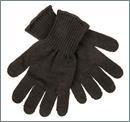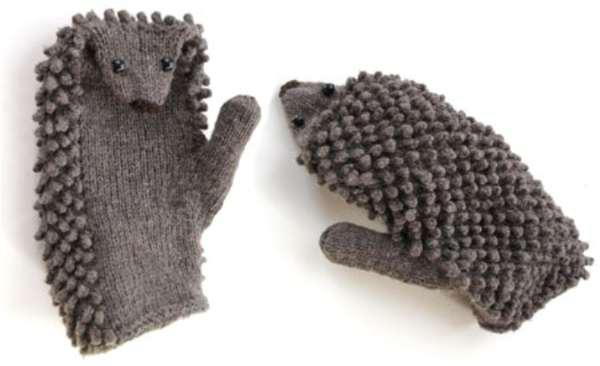The first image is the image on the left, the second image is the image on the right. Evaluate the accuracy of this statement regarding the images: "Two pairs of traditional mittens are shown, with the fingers covered by one rounded section.". Is it true? Answer yes or no. No. 